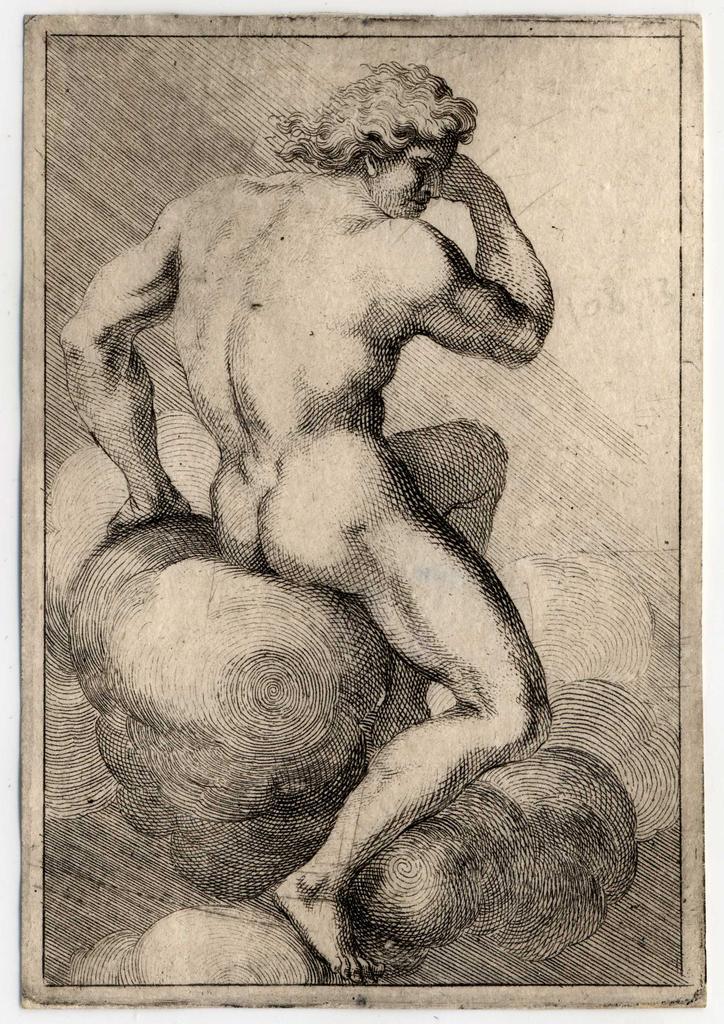Please provide a concise description of this image. This is the picture of a poster and we can see the black and white figure drawing of a human. 